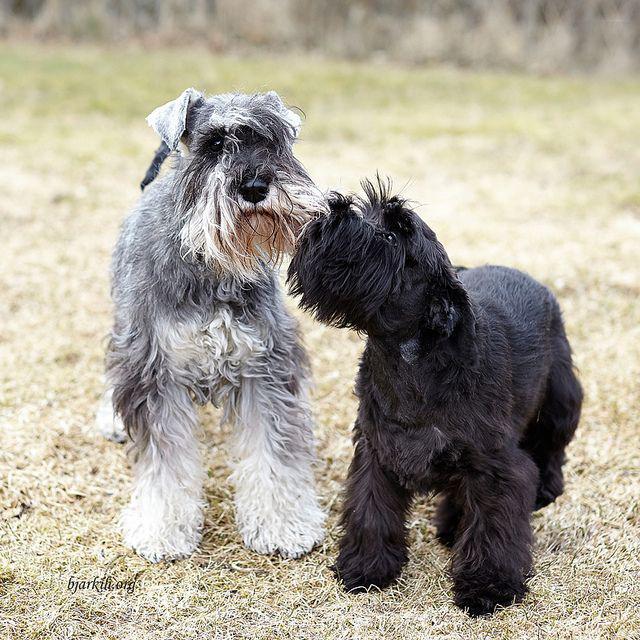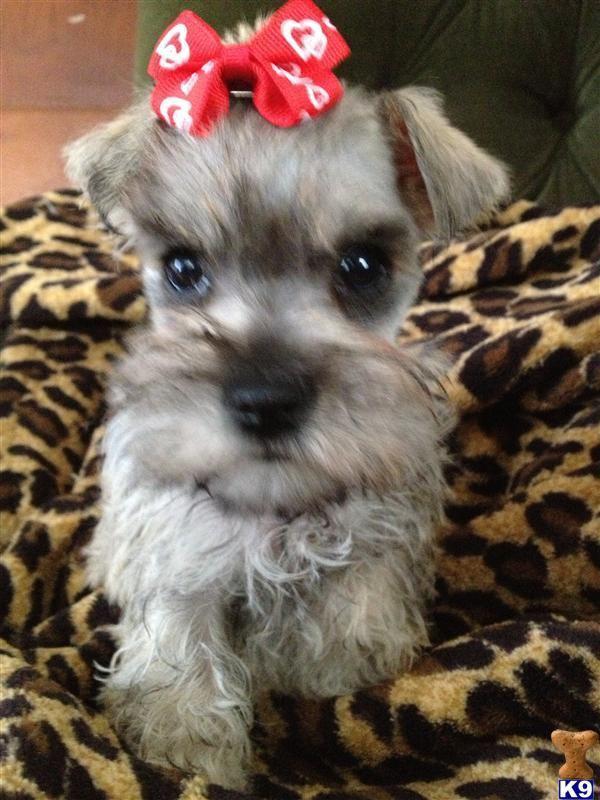The first image is the image on the left, the second image is the image on the right. Evaluate the accuracy of this statement regarding the images: "Some of the dogs are inside and the others are outside in the grass.". Is it true? Answer yes or no. Yes. The first image is the image on the left, the second image is the image on the right. For the images shown, is this caption "In one image, there are two Miniature Schnauzers sitting on some furniture." true? Answer yes or no. No. 